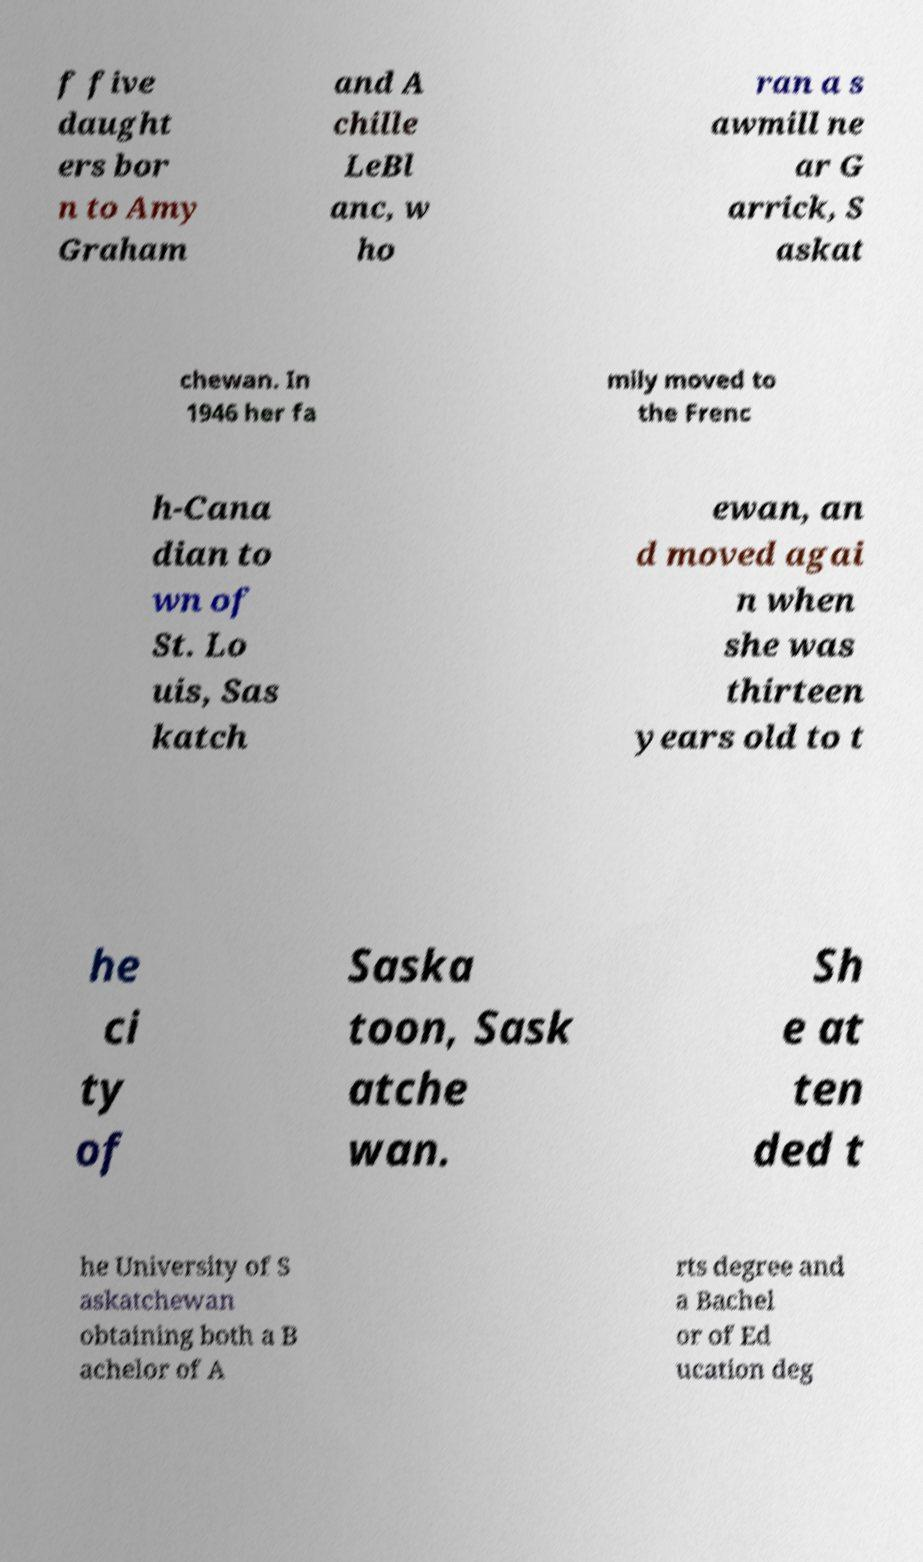Could you extract and type out the text from this image? f five daught ers bor n to Amy Graham and A chille LeBl anc, w ho ran a s awmill ne ar G arrick, S askat chewan. In 1946 her fa mily moved to the Frenc h-Cana dian to wn of St. Lo uis, Sas katch ewan, an d moved agai n when she was thirteen years old to t he ci ty of Saska toon, Sask atche wan. Sh e at ten ded t he University of S askatchewan obtaining both a B achelor of A rts degree and a Bachel or of Ed ucation deg 